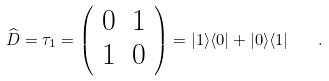<formula> <loc_0><loc_0><loc_500><loc_500>\widehat { D } = \tau _ { 1 } = \left ( \begin{array} { c c } 0 & 1 \\ 1 & 0 \end{array} \right ) = | 1 \rangle \langle 0 | + | 0 \rangle \langle 1 | \quad .</formula> 